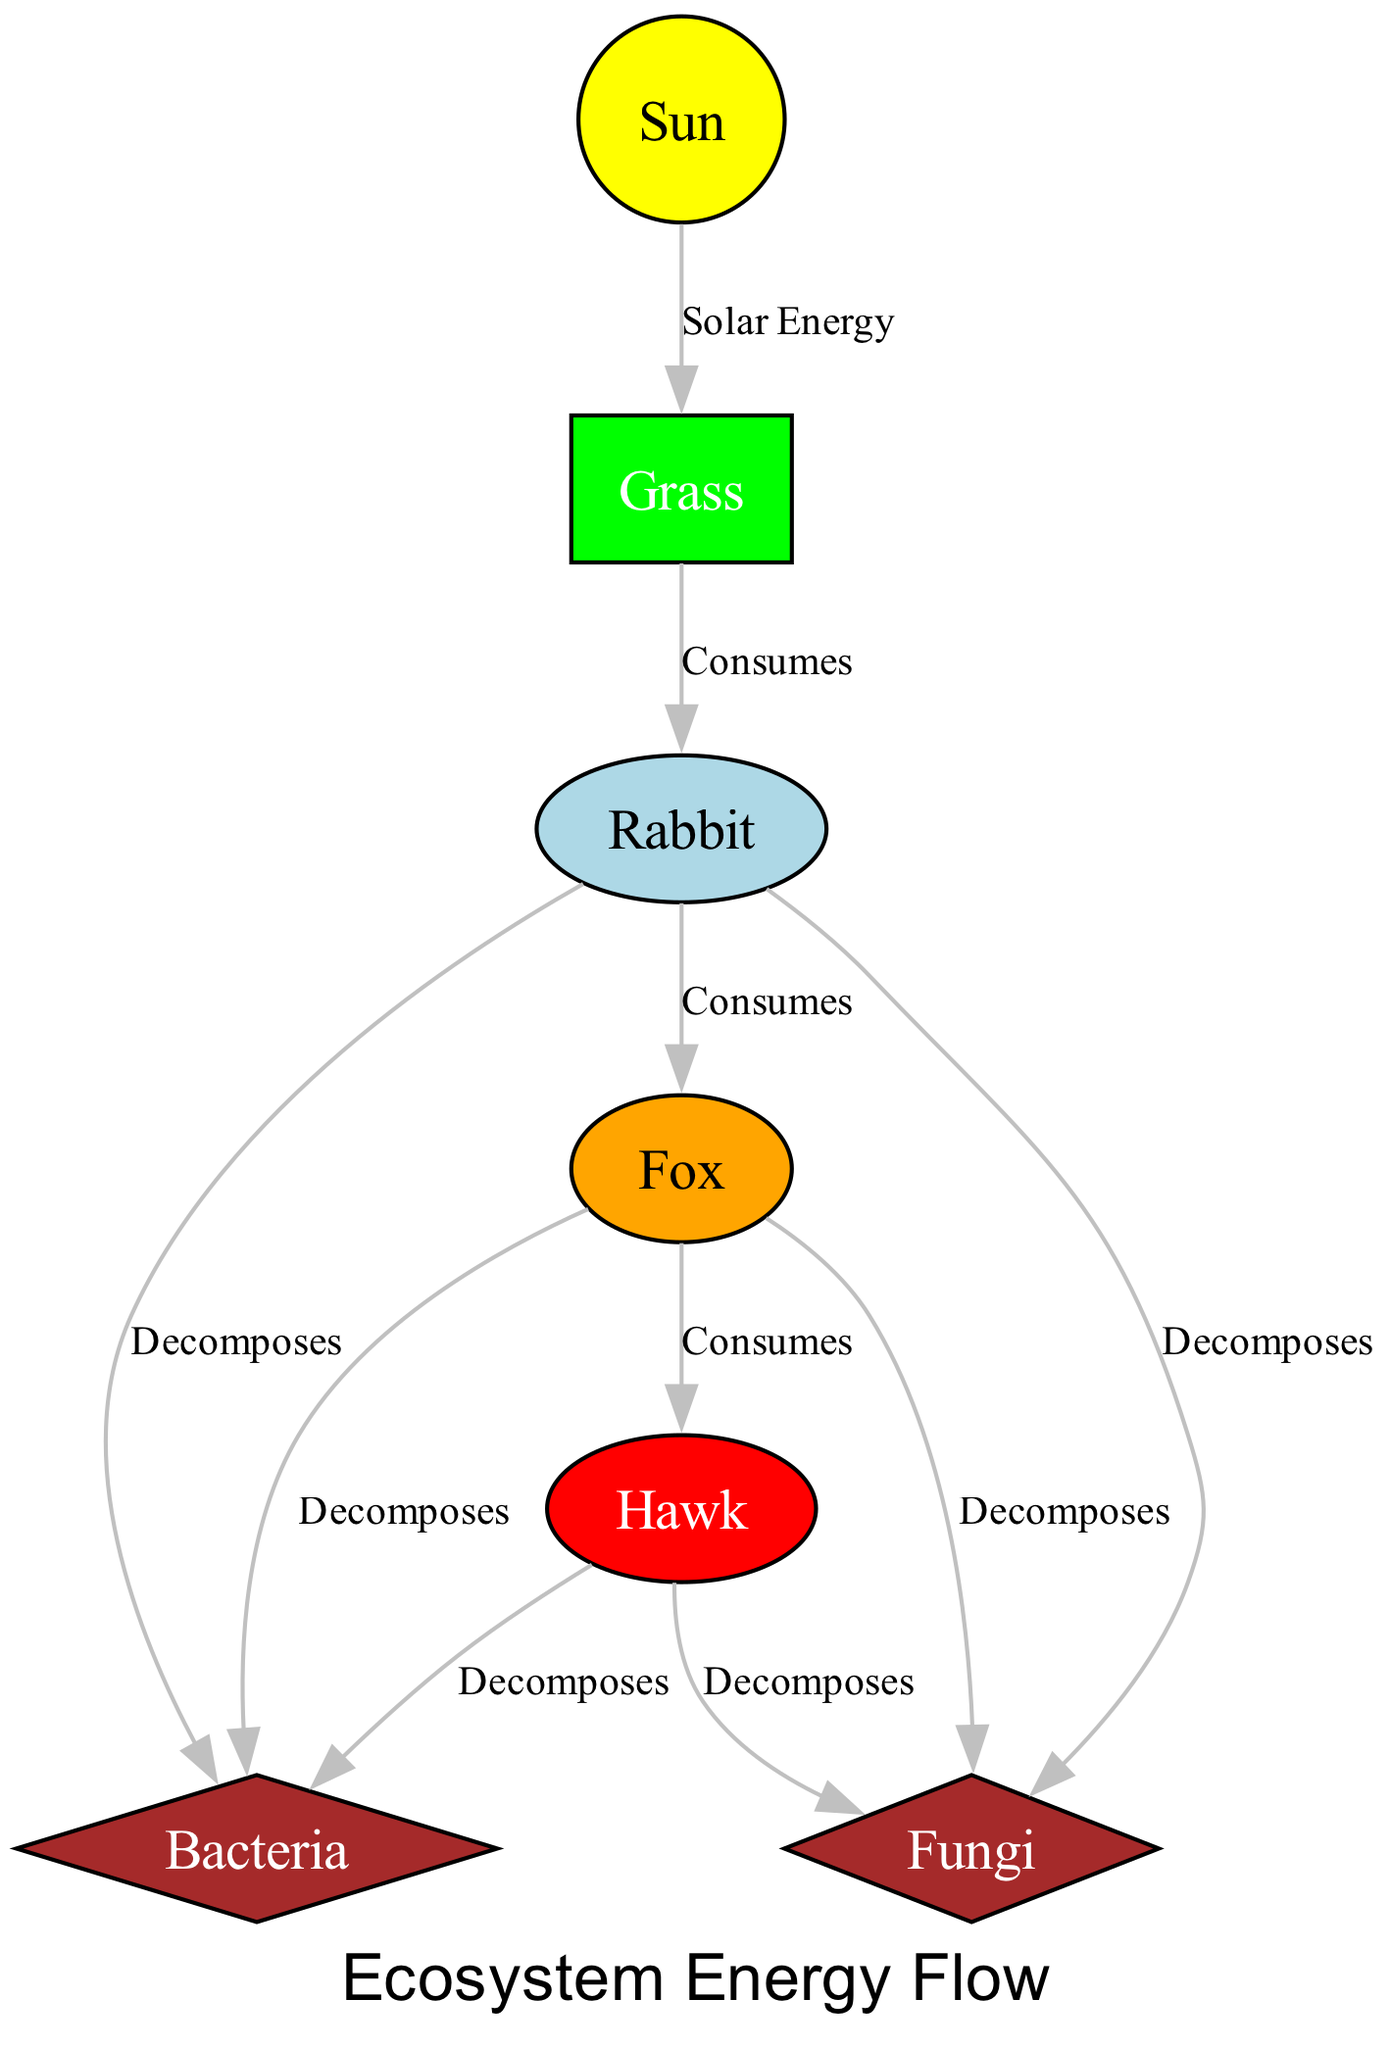What is the energy source in the ecosystem? In the diagram, the node labeled "Sun" represents the primary energy source for the ecosystem. It is where energy originates, powering the primary producers.
Answer: Sun How many primary producers are shown in the diagram? From the diagram, we can see that there is one primary producer, which is the "Grass". Counting the nodes of this type confirms there is only one.
Answer: 1 What type of consumer is a fox? The diagram classifies the "Fox" as a secondary consumer based on its position within the energy flow diagram. It consumes primary consumers, specifically the "Rabbit".
Answer: Secondary Consumer Which organism is at the top of the energy flow? The "Hawk" is located at the top of the energy flow in the diagram, indicating it is a tertiary consumer that preys on secondary consumers like the "Fox".
Answer: Hawk How many decomposers are present in the ecosystem? The diagram indicates there are two decomposers: "Bacteria" and "Fungi." Both nodes are present, which can be counted directly from the diagram.
Answer: 2 What relationship exists between rabbits and bacteria? The diagram illustrates that rabbits contribute to the decomposition process by being a food source for bacteria, as indicated by the edge labeled "Decomposes".
Answer: Decomposes Which organism consumes grass? The "Rabbit" consumes the grass, as shown in the diagram with an edge labeled "Consumes" connecting the "Grass" node to the "Rabbit" node.
Answer: Rabbit What color represents primary producers in the diagram? In the diagram, primary producers like "Grass" are represented by a green color, allowing for easy visual identification among other organism types.
Answer: Green Which two organisms are decomposers in the ecosystem? The diagram shows that "Bacteria" and "Fungi" are the two decomposers identified in the ecosystem, both helping to break down organic matter.
Answer: Bacteria and Fungi 